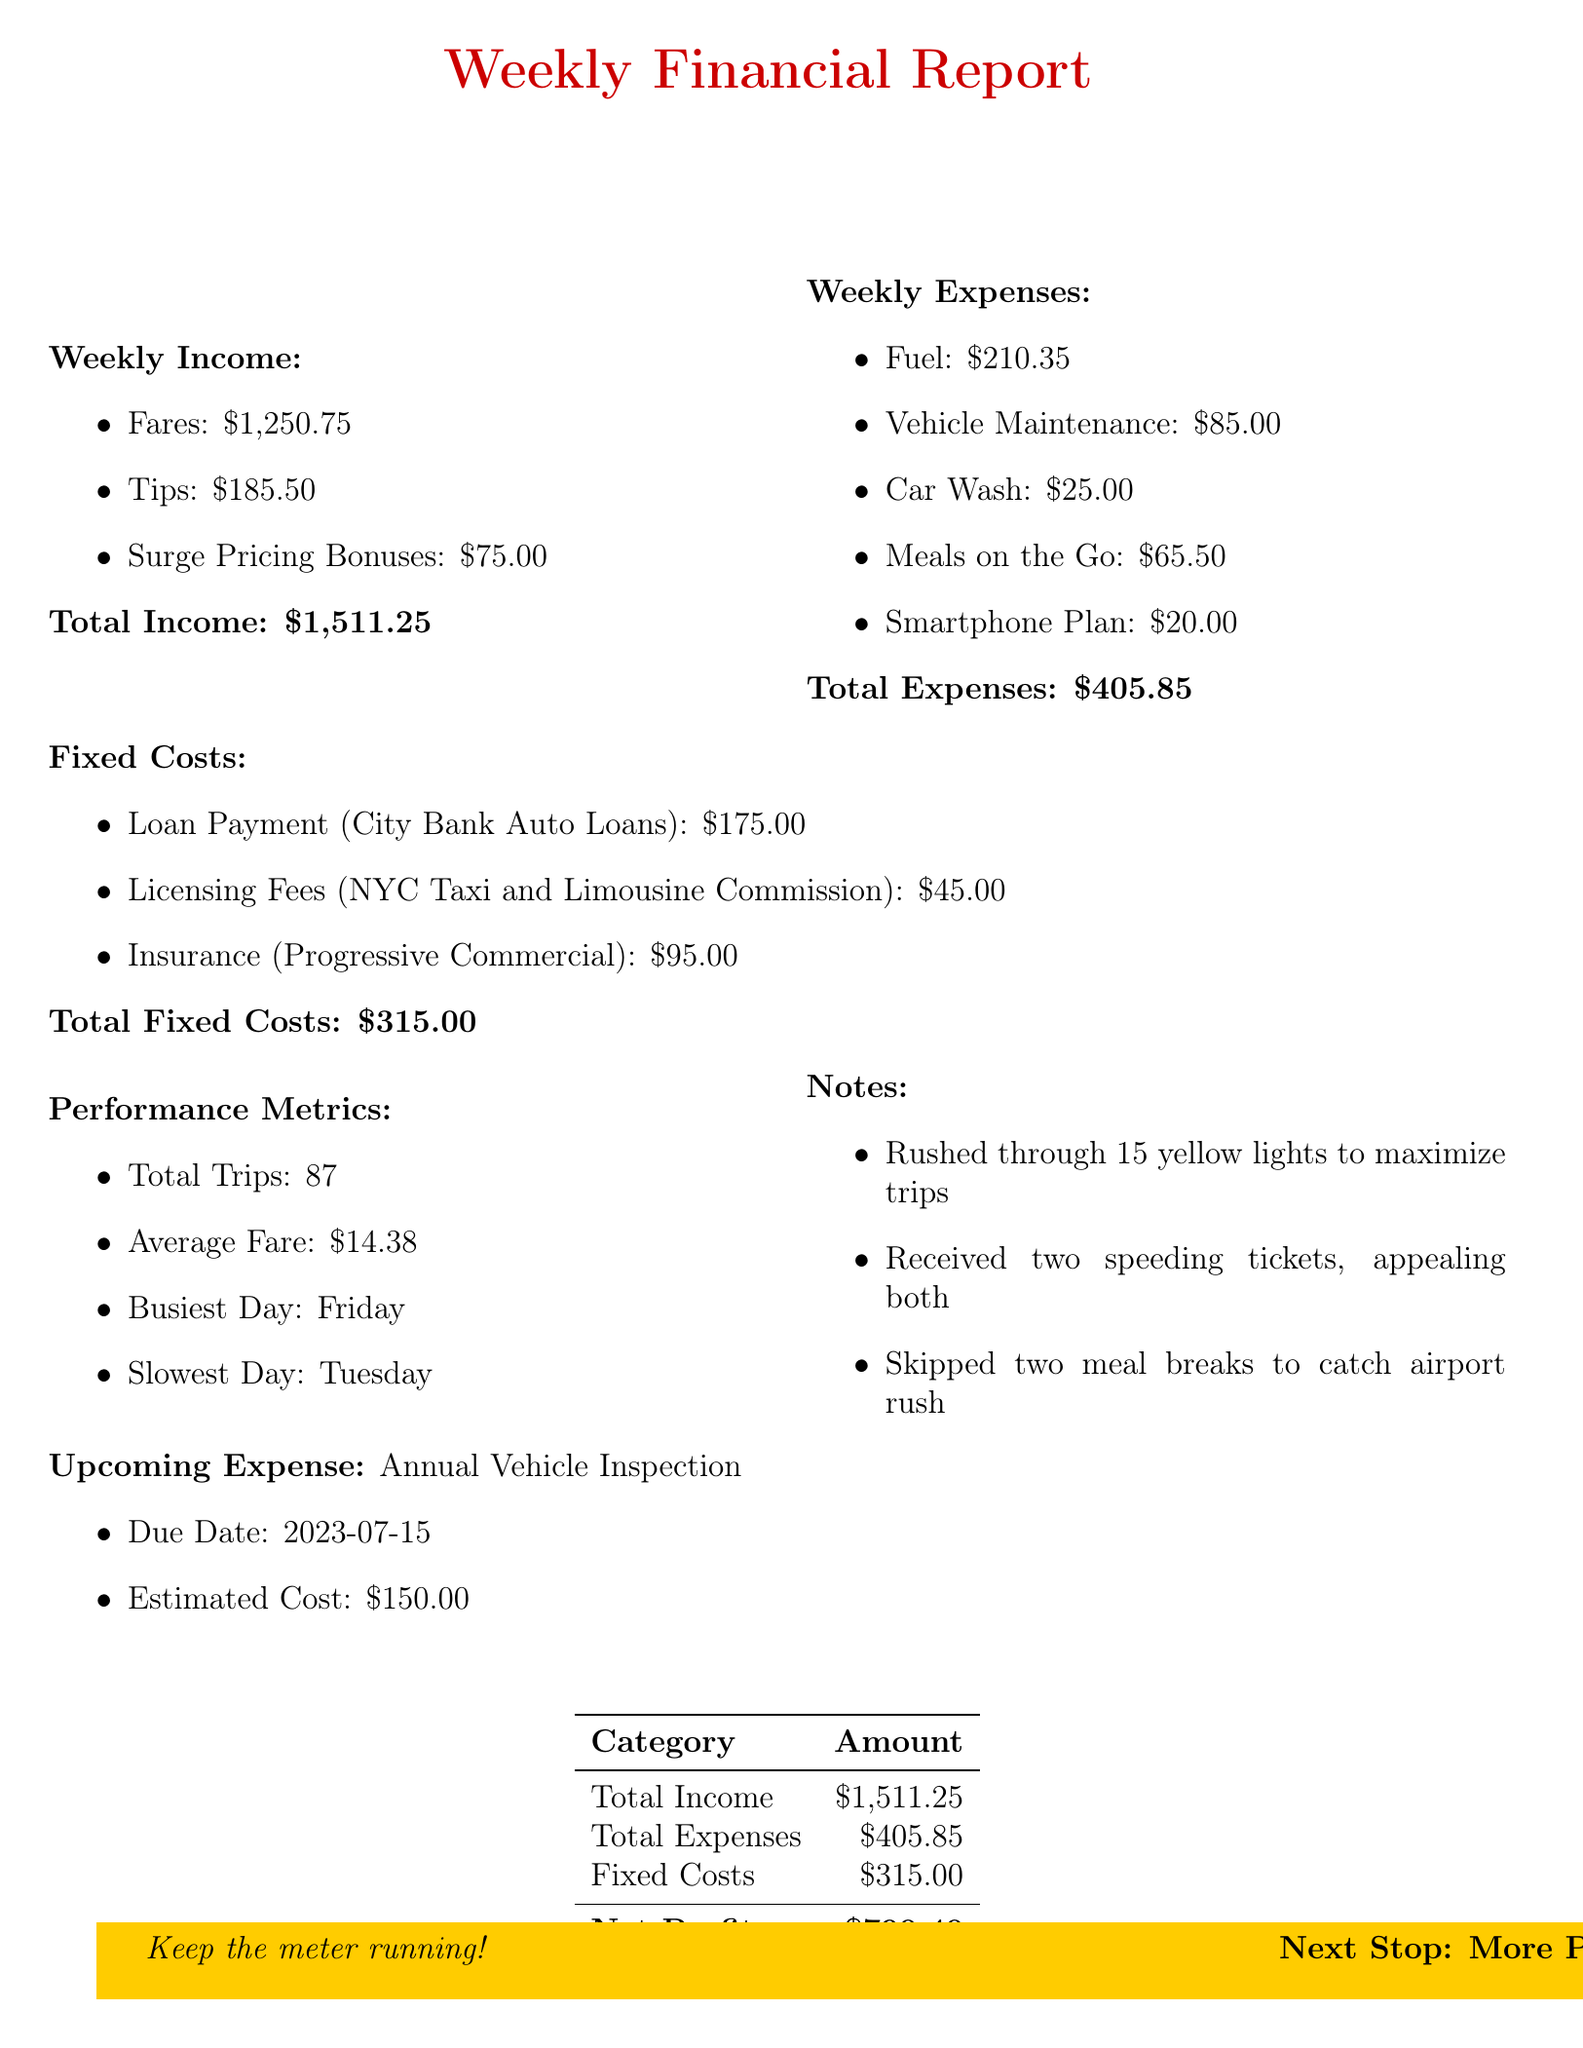what is the total income? The total income is the sum of fares, tips, and surge pricing bonuses, which is $1250.75 + $185.50 + $75.00 = $1511.25.
Answer: $1511.25 what are the licensing fees? The licensing fees are mentioned as due to the New York City Taxi and Limousine Commission.
Answer: $45.00 what is the net profit? The net profit is the difference between total income and total expenses minus fixed costs, which is $1511.25 - $405.85 - $315.00 = $790.40.
Answer: $790.40 which day was the busiest? The busiest day is indicated in the performance metrics.
Answer: Friday how much was spent on meals on the go? The document lists the expenses for meals on the go.
Answer: $65.50 what is the due date for the annual vehicle inspection? The upcoming expense specifies the due date for the annual vehicle inspection.
Answer: 2023-07-15 what is the total expenses? The total expenses are the sum of all weekly expenses listed in the document.
Answer: $405.85 who is the insurance provider? The fixed costs section specifies the insurance provider for the taxi service.
Answer: Progressive Commercial 